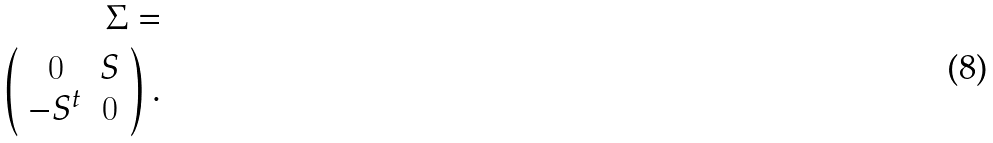<formula> <loc_0><loc_0><loc_500><loc_500>\Sigma = \\ \left ( \begin{array} { c c } 0 & S \\ - S ^ { t } & 0 \end{array} \right ) .</formula> 